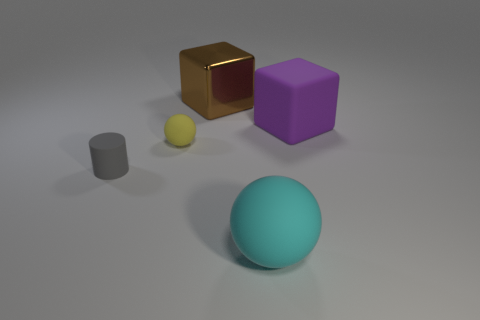Add 5 tiny gray shiny objects. How many objects exist? 10 Subtract 1 spheres. How many spheres are left? 1 Subtract all cylinders. How many objects are left? 4 Subtract all cyan balls. How many balls are left? 1 Subtract all gray cubes. Subtract all brown spheres. How many cubes are left? 2 Subtract all red cubes. How many brown cylinders are left? 0 Subtract all cyan spheres. Subtract all tiny cyan objects. How many objects are left? 4 Add 2 tiny cylinders. How many tiny cylinders are left? 3 Add 1 cyan matte spheres. How many cyan matte spheres exist? 2 Subtract 0 green cylinders. How many objects are left? 5 